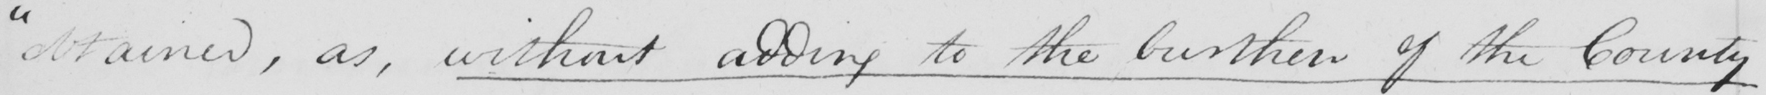Can you tell me what this handwritten text says? " obtained , as , without adding to the burthen of the County- 